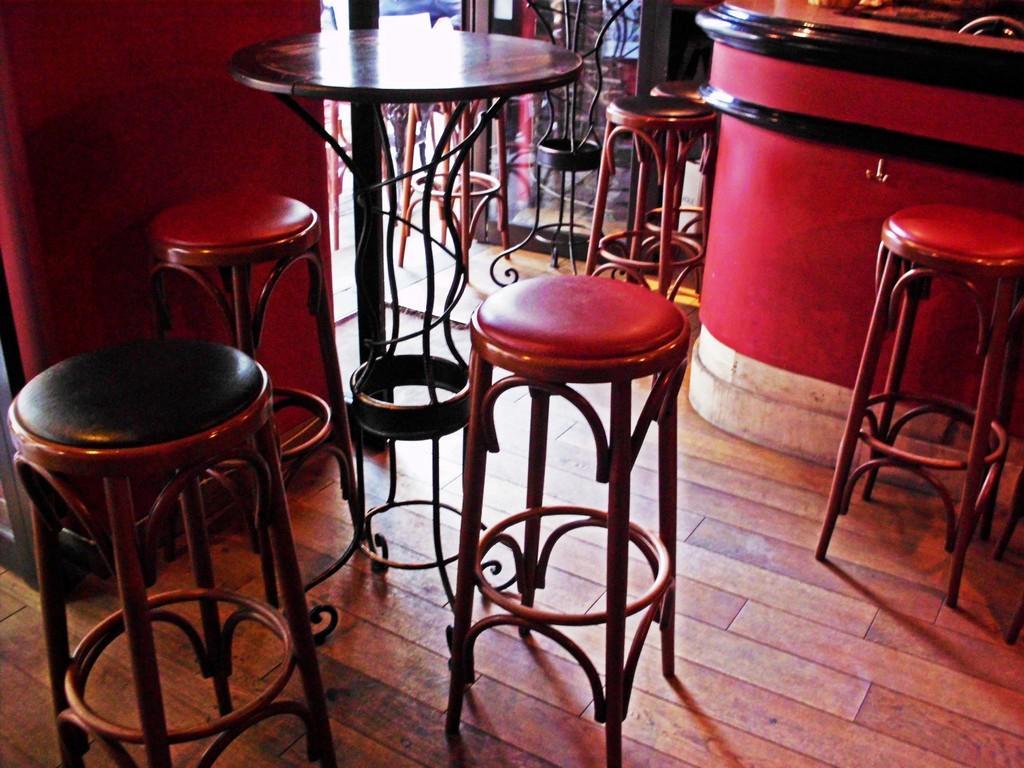Please provide a concise description of this image. In this image, we can see some stools. There is a table at the top of the image. There is a counter in the top right of the image. 